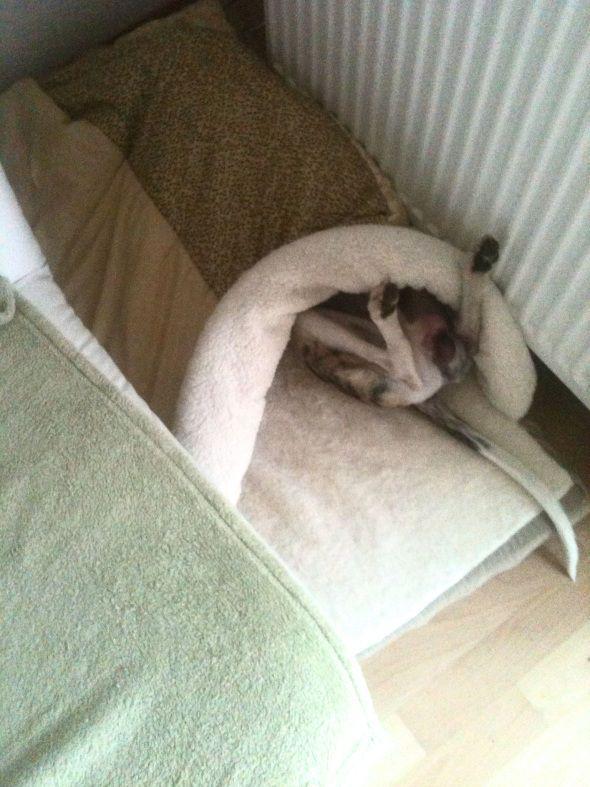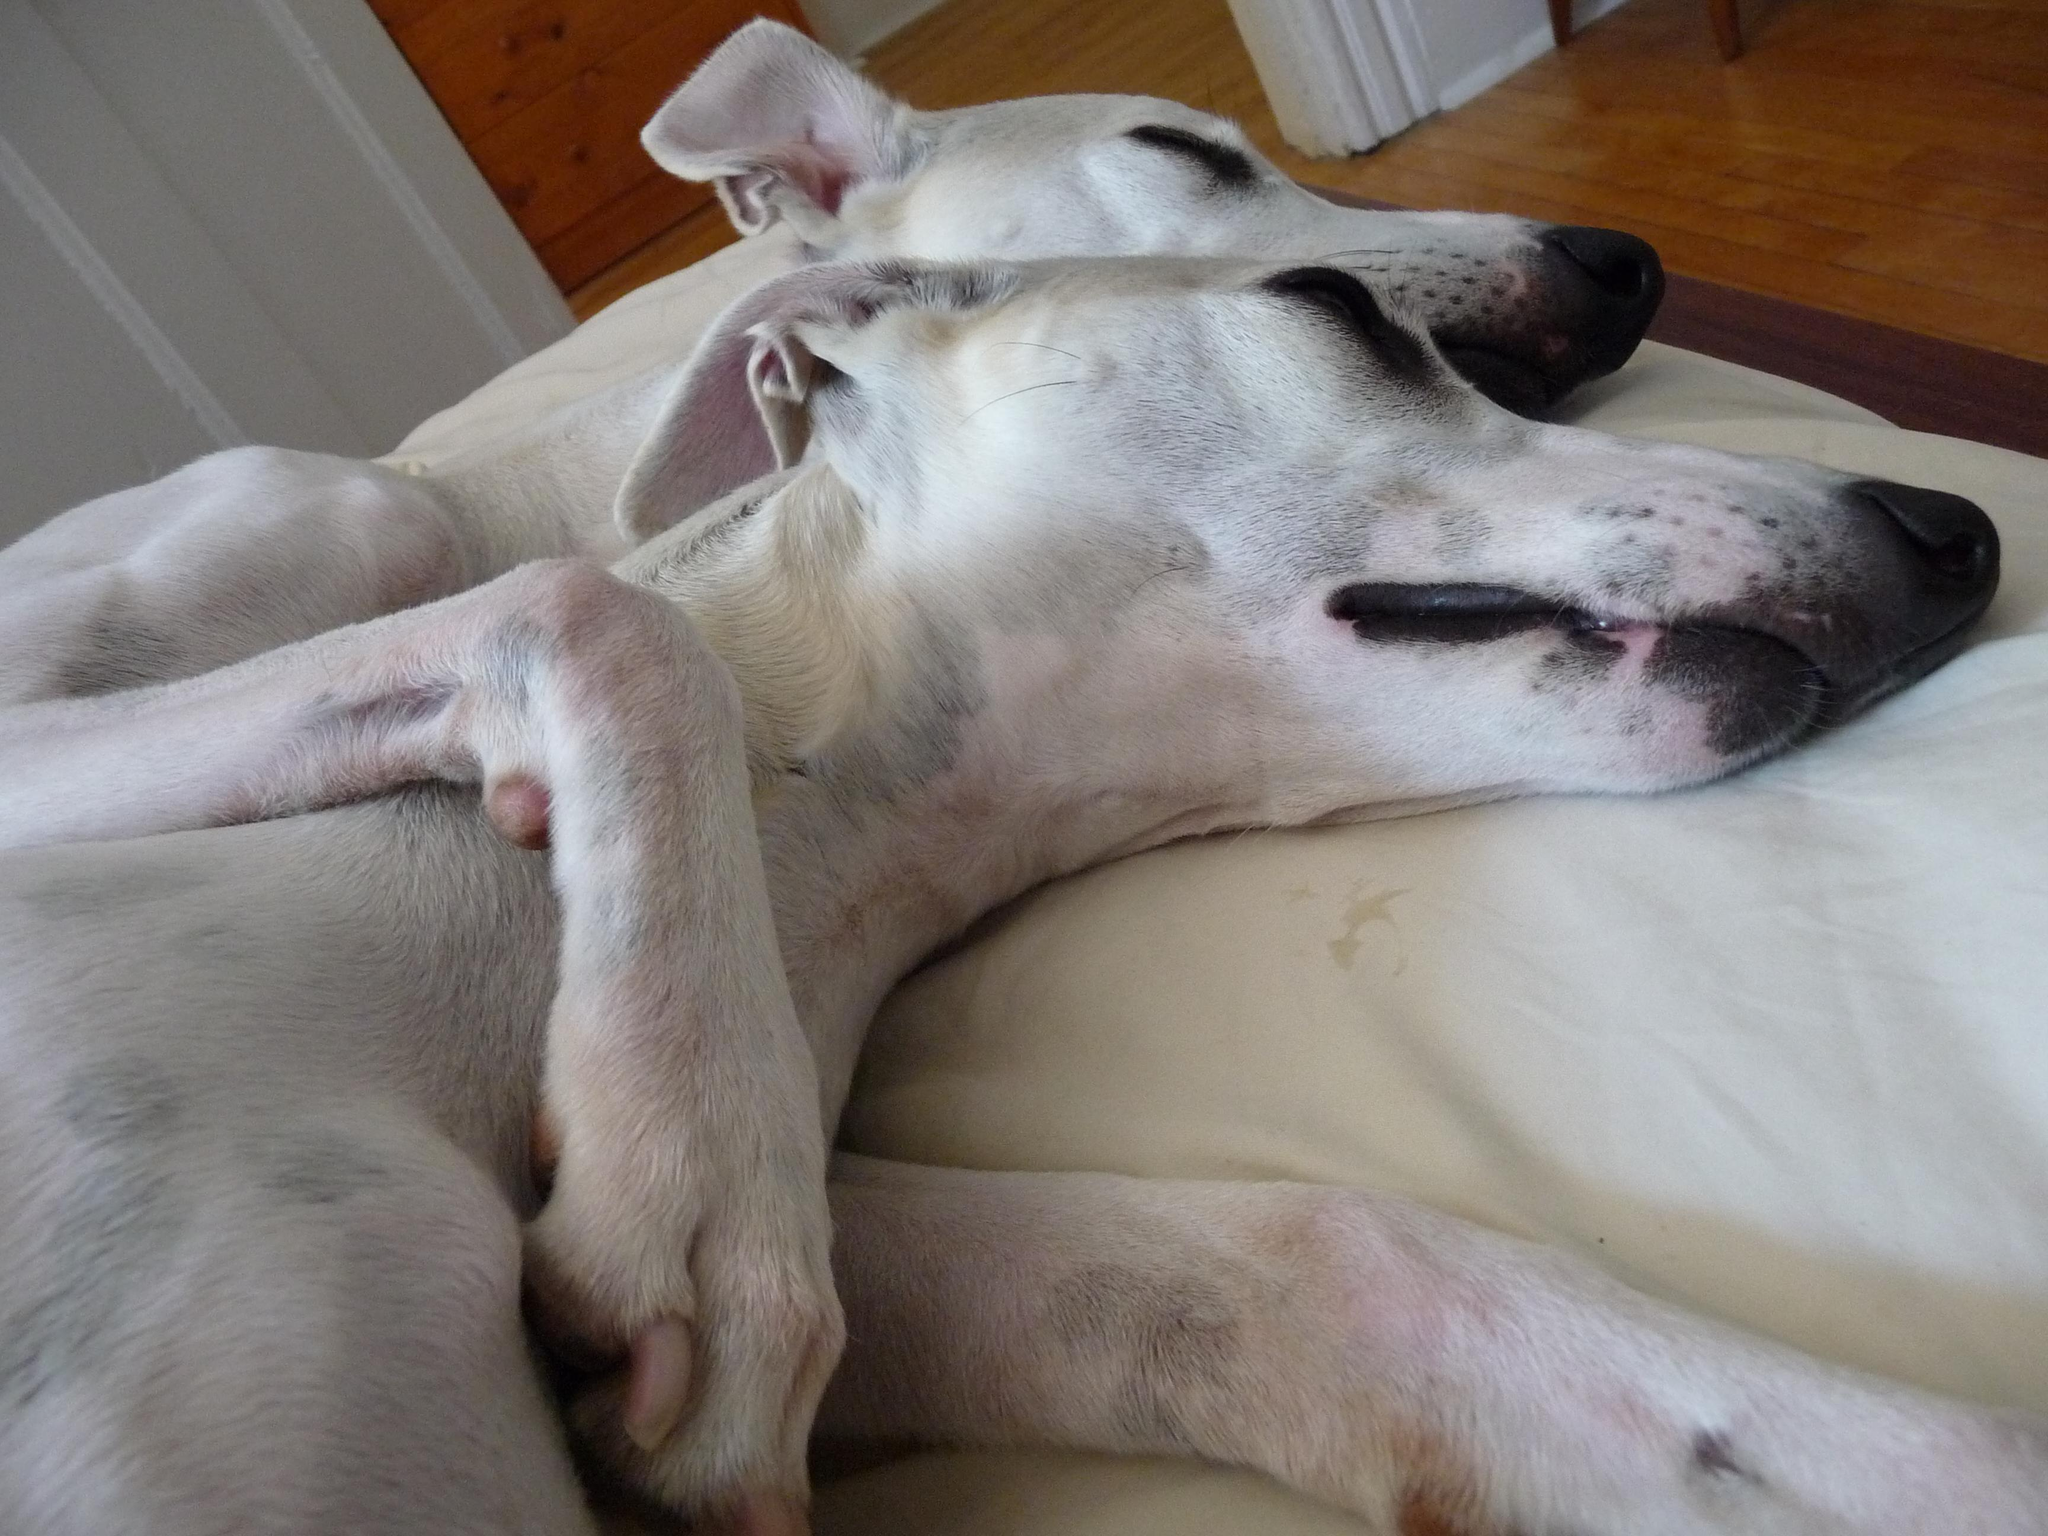The first image is the image on the left, the second image is the image on the right. For the images shown, is this caption "There are a total of three dogs." true? Answer yes or no. Yes. The first image is the image on the left, the second image is the image on the right. Considering the images on both sides, is "A dog is sleeping with another dog in at least one picture." valid? Answer yes or no. Yes. 